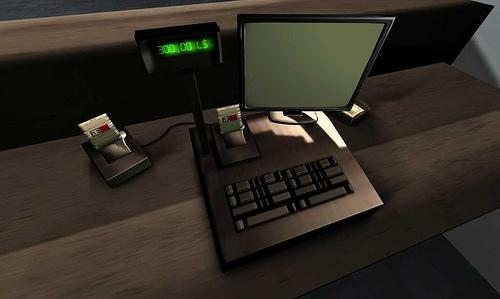Describe the appearance of the keyboard in the image. The keyboard is black, flat, and has different sizes of buttons on it. What is the object with green writing on and what color is the writing? The object with green writing is a register and the writing is glowing green. What color is the lettering on the register and what does it say? The lettering is green and it says "30000 l." Find a small object that holds a calendar and describe its appearance. There is a small box that holds the calendar, which is white and red in color. Determine the color and type of the floor in the image. The floor is dark gray and has dark gray flooring. What is the color and material of the counter where the machine is sitting? The counter is brown and made of wood. What does the timer display connected to the computer say? The timer display says "30000 l." Identify the color and object type of the monitor in the image. The monitor is black and its object type is a computer monitor. Describe the connection between the machine and the black pole. There is a small screen connected to the black pole with a black wire connecting the machine. What is the color of the wall and its material? The wall is gray in color and made of wood. 